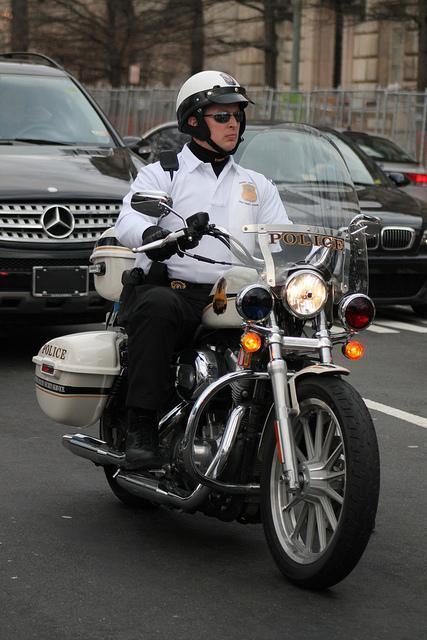How many cars can you see?
Give a very brief answer. 3. 